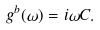<formula> <loc_0><loc_0><loc_500><loc_500>g ^ { b } ( \omega ) = i \omega C .</formula> 